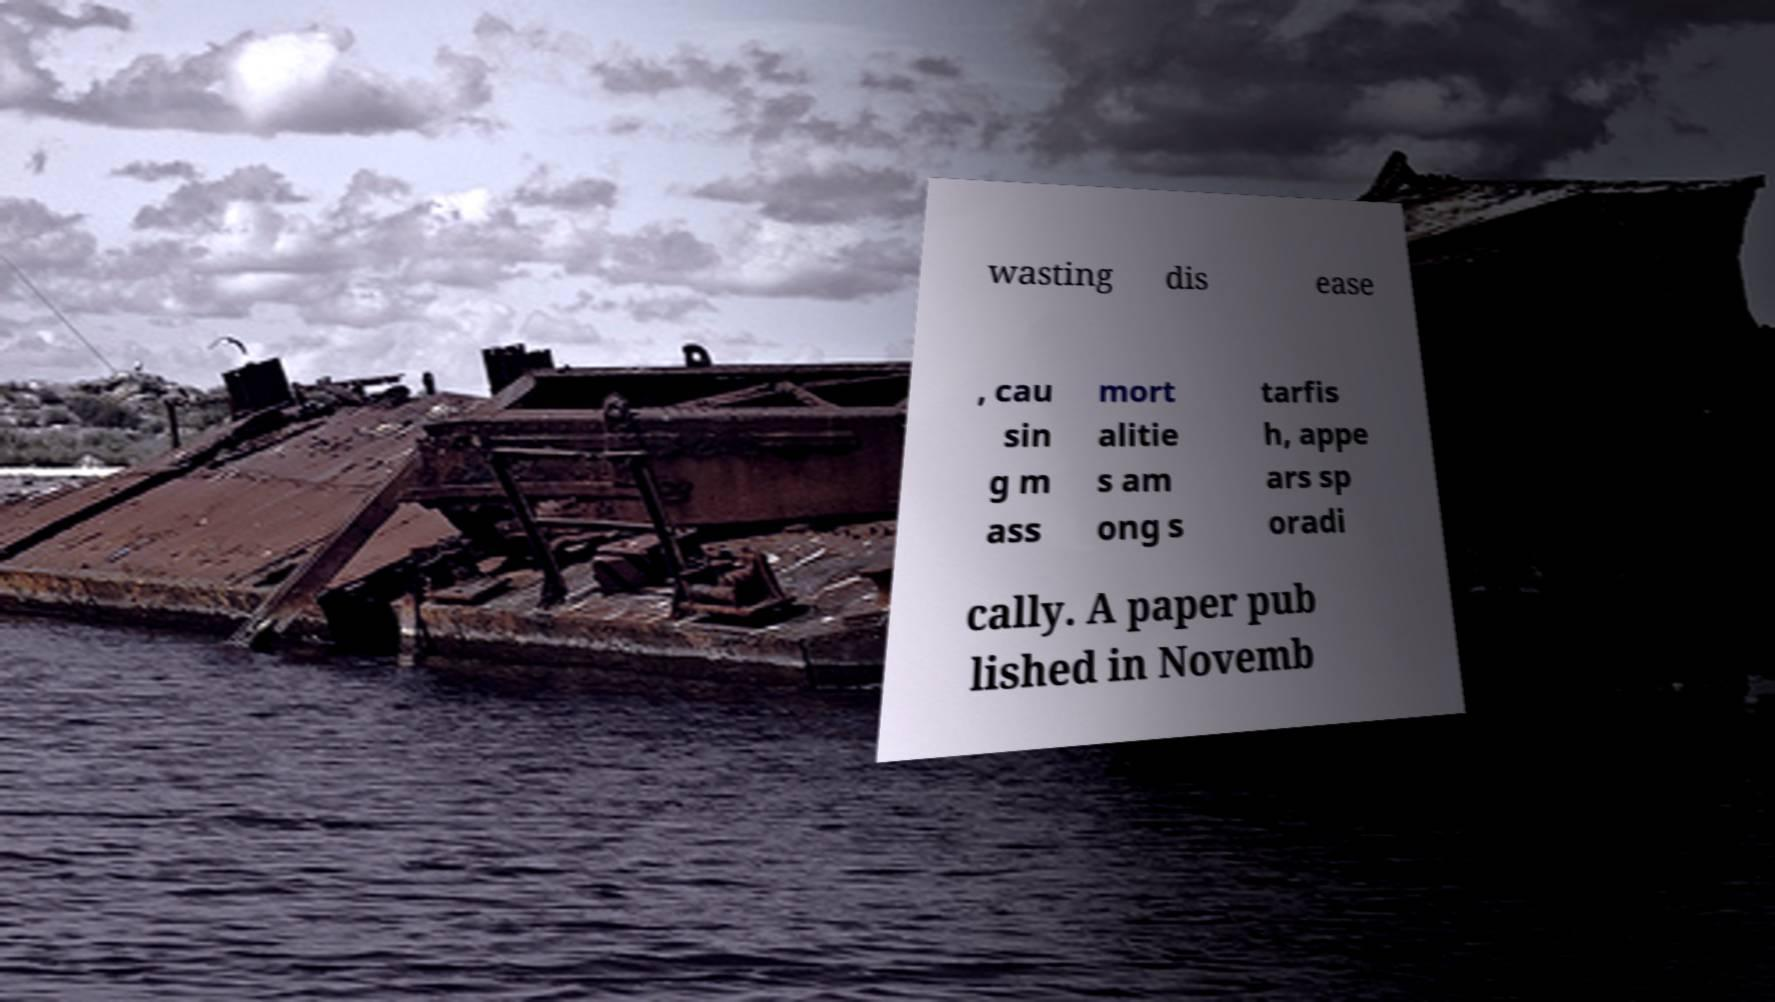Could you assist in decoding the text presented in this image and type it out clearly? wasting dis ease , cau sin g m ass mort alitie s am ong s tarfis h, appe ars sp oradi cally. A paper pub lished in Novemb 